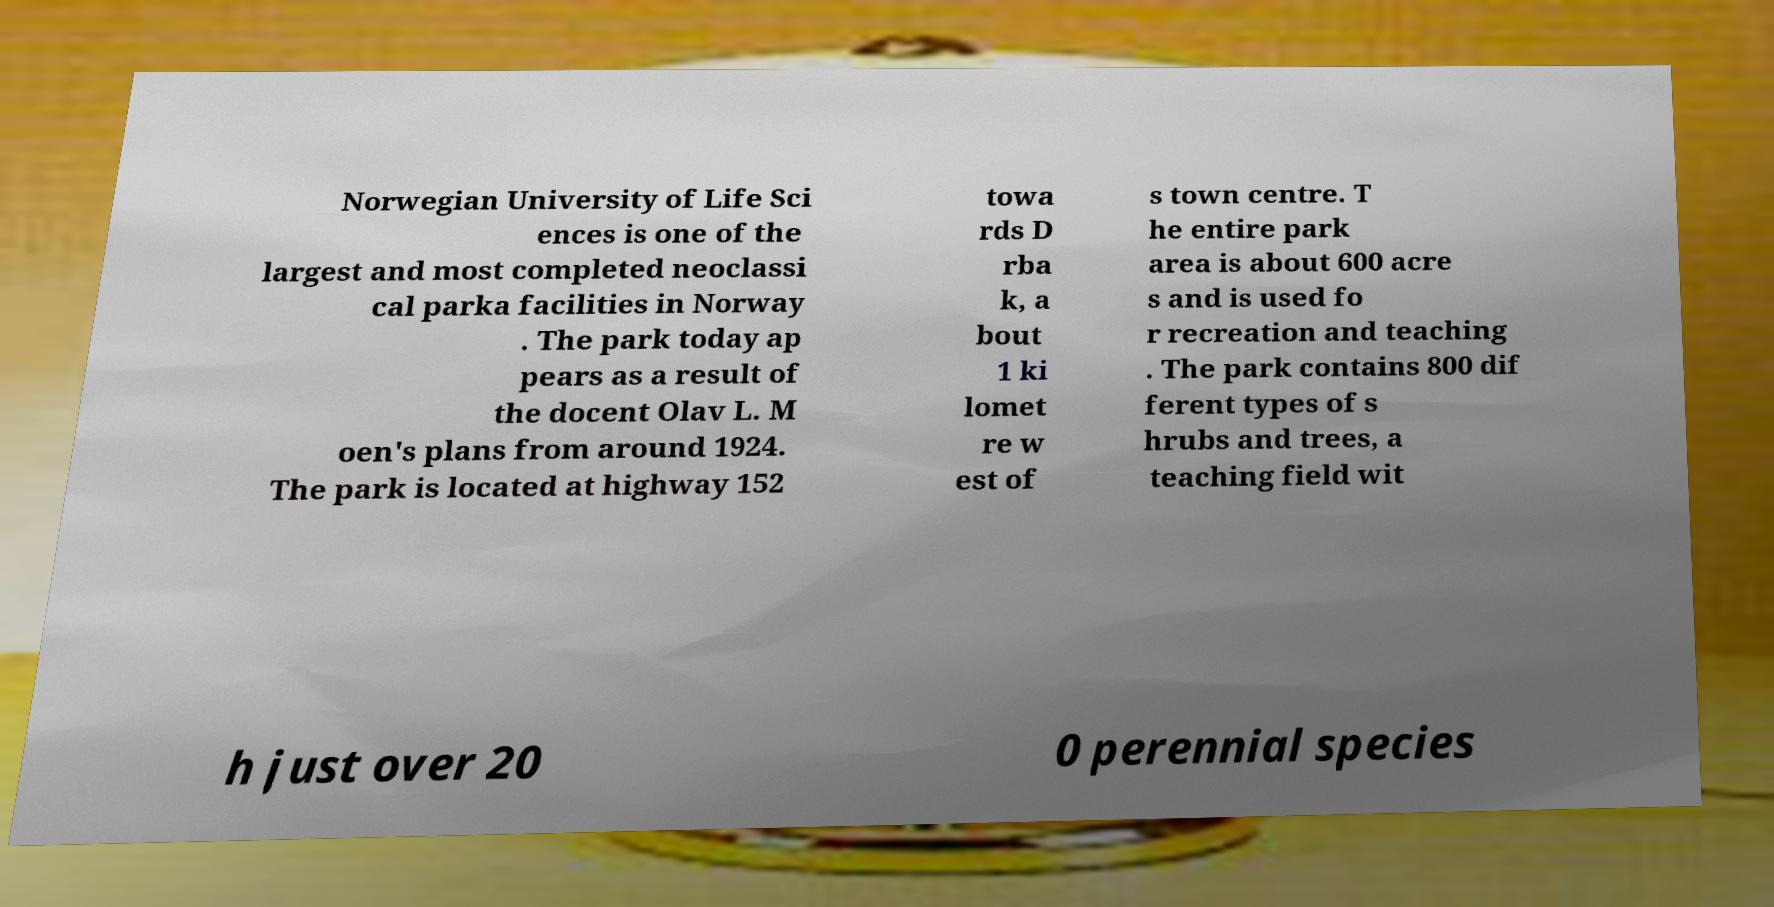Please read and relay the text visible in this image. What does it say? Norwegian University of Life Sci ences is one of the largest and most completed neoclassi cal parka facilities in Norway . The park today ap pears as a result of the docent Olav L. M oen's plans from around 1924. The park is located at highway 152 towa rds D rba k, a bout 1 ki lomet re w est of s town centre. T he entire park area is about 600 acre s and is used fo r recreation and teaching . The park contains 800 dif ferent types of s hrubs and trees, a teaching field wit h just over 20 0 perennial species 